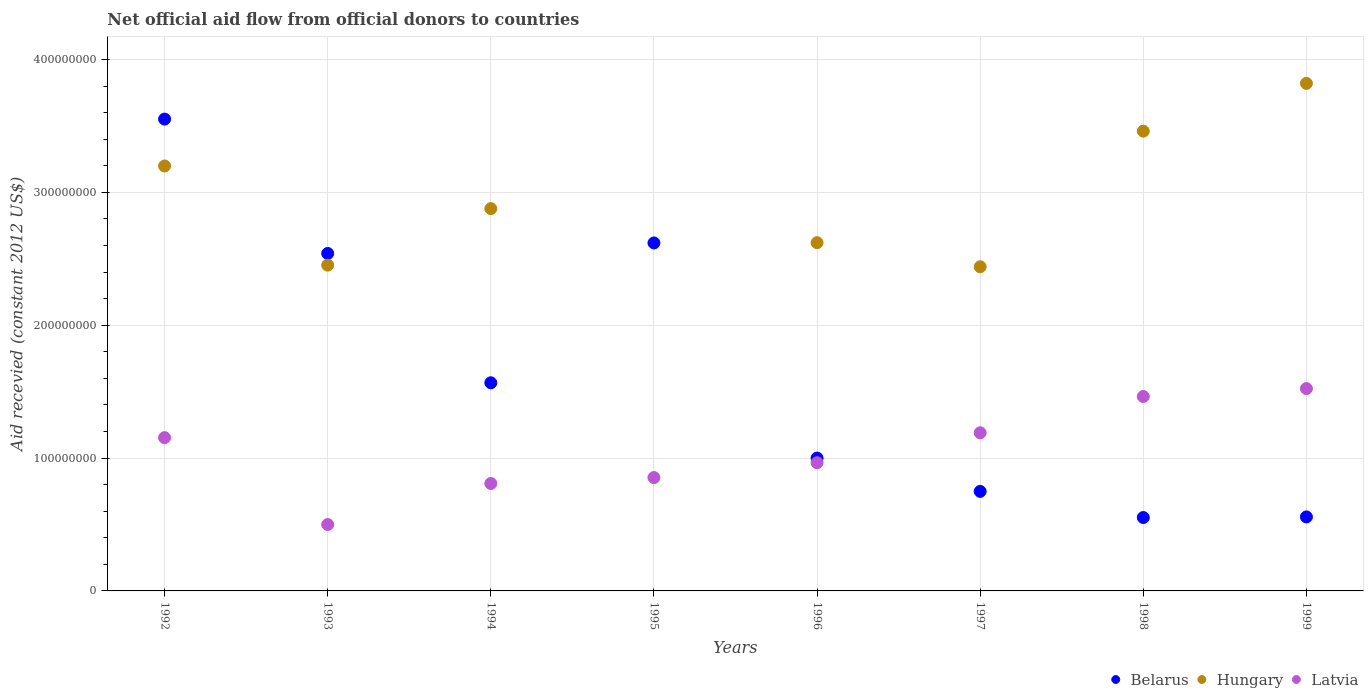How many different coloured dotlines are there?
Provide a succinct answer. 3. Is the number of dotlines equal to the number of legend labels?
Give a very brief answer. No. What is the total aid received in Hungary in 1997?
Provide a short and direct response. 2.44e+08. Across all years, what is the maximum total aid received in Belarus?
Your response must be concise. 3.55e+08. Across all years, what is the minimum total aid received in Latvia?
Give a very brief answer. 5.00e+07. What is the total total aid received in Belarus in the graph?
Keep it short and to the point. 1.31e+09. What is the difference between the total aid received in Latvia in 1993 and that in 1998?
Provide a succinct answer. -9.64e+07. What is the difference between the total aid received in Belarus in 1992 and the total aid received in Latvia in 1999?
Your response must be concise. 2.03e+08. What is the average total aid received in Hungary per year?
Keep it short and to the point. 2.61e+08. In the year 1997, what is the difference between the total aid received in Belarus and total aid received in Hungary?
Your answer should be compact. -1.69e+08. In how many years, is the total aid received in Latvia greater than 100000000 US$?
Provide a succinct answer. 4. What is the ratio of the total aid received in Belarus in 1995 to that in 1999?
Your response must be concise. 4.7. What is the difference between the highest and the second highest total aid received in Latvia?
Offer a very short reply. 5.96e+06. What is the difference between the highest and the lowest total aid received in Belarus?
Make the answer very short. 3.00e+08. Is the sum of the total aid received in Latvia in 1995 and 1997 greater than the maximum total aid received in Belarus across all years?
Your response must be concise. No. Is it the case that in every year, the sum of the total aid received in Latvia and total aid received in Hungary  is greater than the total aid received in Belarus?
Keep it short and to the point. No. Is the total aid received in Hungary strictly greater than the total aid received in Belarus over the years?
Make the answer very short. No. How many dotlines are there?
Keep it short and to the point. 3. Where does the legend appear in the graph?
Offer a very short reply. Bottom right. How many legend labels are there?
Ensure brevity in your answer.  3. What is the title of the graph?
Give a very brief answer. Net official aid flow from official donors to countries. Does "Channel Islands" appear as one of the legend labels in the graph?
Your answer should be compact. No. What is the label or title of the X-axis?
Ensure brevity in your answer.  Years. What is the label or title of the Y-axis?
Ensure brevity in your answer.  Aid recevied (constant 2012 US$). What is the Aid recevied (constant 2012 US$) of Belarus in 1992?
Offer a very short reply. 3.55e+08. What is the Aid recevied (constant 2012 US$) of Hungary in 1992?
Keep it short and to the point. 3.20e+08. What is the Aid recevied (constant 2012 US$) in Latvia in 1992?
Make the answer very short. 1.15e+08. What is the Aid recevied (constant 2012 US$) in Belarus in 1993?
Ensure brevity in your answer.  2.54e+08. What is the Aid recevied (constant 2012 US$) in Hungary in 1993?
Keep it short and to the point. 2.45e+08. What is the Aid recevied (constant 2012 US$) in Latvia in 1993?
Ensure brevity in your answer.  5.00e+07. What is the Aid recevied (constant 2012 US$) in Belarus in 1994?
Give a very brief answer. 1.57e+08. What is the Aid recevied (constant 2012 US$) of Hungary in 1994?
Your response must be concise. 2.88e+08. What is the Aid recevied (constant 2012 US$) in Latvia in 1994?
Offer a very short reply. 8.09e+07. What is the Aid recevied (constant 2012 US$) of Belarus in 1995?
Keep it short and to the point. 2.62e+08. What is the Aid recevied (constant 2012 US$) of Latvia in 1995?
Offer a terse response. 8.53e+07. What is the Aid recevied (constant 2012 US$) of Hungary in 1996?
Make the answer very short. 2.62e+08. What is the Aid recevied (constant 2012 US$) in Latvia in 1996?
Keep it short and to the point. 9.65e+07. What is the Aid recevied (constant 2012 US$) in Belarus in 1997?
Give a very brief answer. 7.49e+07. What is the Aid recevied (constant 2012 US$) of Hungary in 1997?
Provide a succinct answer. 2.44e+08. What is the Aid recevied (constant 2012 US$) in Latvia in 1997?
Your response must be concise. 1.19e+08. What is the Aid recevied (constant 2012 US$) in Belarus in 1998?
Your response must be concise. 5.52e+07. What is the Aid recevied (constant 2012 US$) of Hungary in 1998?
Make the answer very short. 3.46e+08. What is the Aid recevied (constant 2012 US$) of Latvia in 1998?
Your response must be concise. 1.46e+08. What is the Aid recevied (constant 2012 US$) in Belarus in 1999?
Your response must be concise. 5.57e+07. What is the Aid recevied (constant 2012 US$) of Hungary in 1999?
Make the answer very short. 3.82e+08. What is the Aid recevied (constant 2012 US$) in Latvia in 1999?
Make the answer very short. 1.52e+08. Across all years, what is the maximum Aid recevied (constant 2012 US$) in Belarus?
Keep it short and to the point. 3.55e+08. Across all years, what is the maximum Aid recevied (constant 2012 US$) in Hungary?
Make the answer very short. 3.82e+08. Across all years, what is the maximum Aid recevied (constant 2012 US$) of Latvia?
Offer a terse response. 1.52e+08. Across all years, what is the minimum Aid recevied (constant 2012 US$) of Belarus?
Give a very brief answer. 5.52e+07. Across all years, what is the minimum Aid recevied (constant 2012 US$) of Hungary?
Offer a terse response. 0. Across all years, what is the minimum Aid recevied (constant 2012 US$) in Latvia?
Keep it short and to the point. 5.00e+07. What is the total Aid recevied (constant 2012 US$) of Belarus in the graph?
Ensure brevity in your answer.  1.31e+09. What is the total Aid recevied (constant 2012 US$) in Hungary in the graph?
Provide a short and direct response. 2.09e+09. What is the total Aid recevied (constant 2012 US$) in Latvia in the graph?
Keep it short and to the point. 8.46e+08. What is the difference between the Aid recevied (constant 2012 US$) of Belarus in 1992 and that in 1993?
Give a very brief answer. 1.01e+08. What is the difference between the Aid recevied (constant 2012 US$) in Hungary in 1992 and that in 1993?
Keep it short and to the point. 7.46e+07. What is the difference between the Aid recevied (constant 2012 US$) of Latvia in 1992 and that in 1993?
Make the answer very short. 6.54e+07. What is the difference between the Aid recevied (constant 2012 US$) in Belarus in 1992 and that in 1994?
Provide a succinct answer. 1.98e+08. What is the difference between the Aid recevied (constant 2012 US$) in Hungary in 1992 and that in 1994?
Ensure brevity in your answer.  3.21e+07. What is the difference between the Aid recevied (constant 2012 US$) of Latvia in 1992 and that in 1994?
Provide a short and direct response. 3.45e+07. What is the difference between the Aid recevied (constant 2012 US$) in Belarus in 1992 and that in 1995?
Give a very brief answer. 9.32e+07. What is the difference between the Aid recevied (constant 2012 US$) in Latvia in 1992 and that in 1995?
Offer a very short reply. 3.00e+07. What is the difference between the Aid recevied (constant 2012 US$) of Belarus in 1992 and that in 1996?
Offer a terse response. 2.55e+08. What is the difference between the Aid recevied (constant 2012 US$) of Hungary in 1992 and that in 1996?
Provide a short and direct response. 5.77e+07. What is the difference between the Aid recevied (constant 2012 US$) in Latvia in 1992 and that in 1996?
Your answer should be compact. 1.88e+07. What is the difference between the Aid recevied (constant 2012 US$) of Belarus in 1992 and that in 1997?
Provide a short and direct response. 2.80e+08. What is the difference between the Aid recevied (constant 2012 US$) in Hungary in 1992 and that in 1997?
Ensure brevity in your answer.  7.59e+07. What is the difference between the Aid recevied (constant 2012 US$) in Latvia in 1992 and that in 1997?
Provide a succinct answer. -3.67e+06. What is the difference between the Aid recevied (constant 2012 US$) in Belarus in 1992 and that in 1998?
Keep it short and to the point. 3.00e+08. What is the difference between the Aid recevied (constant 2012 US$) in Hungary in 1992 and that in 1998?
Make the answer very short. -2.62e+07. What is the difference between the Aid recevied (constant 2012 US$) in Latvia in 1992 and that in 1998?
Make the answer very short. -3.10e+07. What is the difference between the Aid recevied (constant 2012 US$) of Belarus in 1992 and that in 1999?
Keep it short and to the point. 2.99e+08. What is the difference between the Aid recevied (constant 2012 US$) in Hungary in 1992 and that in 1999?
Give a very brief answer. -6.22e+07. What is the difference between the Aid recevied (constant 2012 US$) of Latvia in 1992 and that in 1999?
Provide a succinct answer. -3.69e+07. What is the difference between the Aid recevied (constant 2012 US$) in Belarus in 1993 and that in 1994?
Give a very brief answer. 9.74e+07. What is the difference between the Aid recevied (constant 2012 US$) in Hungary in 1993 and that in 1994?
Offer a terse response. -4.25e+07. What is the difference between the Aid recevied (constant 2012 US$) of Latvia in 1993 and that in 1994?
Offer a terse response. -3.09e+07. What is the difference between the Aid recevied (constant 2012 US$) in Belarus in 1993 and that in 1995?
Offer a very short reply. -7.91e+06. What is the difference between the Aid recevied (constant 2012 US$) in Latvia in 1993 and that in 1995?
Your answer should be very brief. -3.54e+07. What is the difference between the Aid recevied (constant 2012 US$) of Belarus in 1993 and that in 1996?
Provide a succinct answer. 1.54e+08. What is the difference between the Aid recevied (constant 2012 US$) in Hungary in 1993 and that in 1996?
Your response must be concise. -1.69e+07. What is the difference between the Aid recevied (constant 2012 US$) in Latvia in 1993 and that in 1996?
Your response must be concise. -4.66e+07. What is the difference between the Aid recevied (constant 2012 US$) in Belarus in 1993 and that in 1997?
Offer a very short reply. 1.79e+08. What is the difference between the Aid recevied (constant 2012 US$) in Hungary in 1993 and that in 1997?
Offer a very short reply. 1.23e+06. What is the difference between the Aid recevied (constant 2012 US$) of Latvia in 1993 and that in 1997?
Offer a terse response. -6.91e+07. What is the difference between the Aid recevied (constant 2012 US$) in Belarus in 1993 and that in 1998?
Make the answer very short. 1.99e+08. What is the difference between the Aid recevied (constant 2012 US$) in Hungary in 1993 and that in 1998?
Ensure brevity in your answer.  -1.01e+08. What is the difference between the Aid recevied (constant 2012 US$) of Latvia in 1993 and that in 1998?
Your answer should be compact. -9.64e+07. What is the difference between the Aid recevied (constant 2012 US$) of Belarus in 1993 and that in 1999?
Your answer should be very brief. 1.98e+08. What is the difference between the Aid recevied (constant 2012 US$) of Hungary in 1993 and that in 1999?
Your answer should be very brief. -1.37e+08. What is the difference between the Aid recevied (constant 2012 US$) of Latvia in 1993 and that in 1999?
Your response must be concise. -1.02e+08. What is the difference between the Aid recevied (constant 2012 US$) in Belarus in 1994 and that in 1995?
Your response must be concise. -1.05e+08. What is the difference between the Aid recevied (constant 2012 US$) of Latvia in 1994 and that in 1995?
Your response must be concise. -4.45e+06. What is the difference between the Aid recevied (constant 2012 US$) in Belarus in 1994 and that in 1996?
Provide a succinct answer. 5.67e+07. What is the difference between the Aid recevied (constant 2012 US$) in Hungary in 1994 and that in 1996?
Keep it short and to the point. 2.56e+07. What is the difference between the Aid recevied (constant 2012 US$) of Latvia in 1994 and that in 1996?
Your answer should be compact. -1.57e+07. What is the difference between the Aid recevied (constant 2012 US$) in Belarus in 1994 and that in 1997?
Ensure brevity in your answer.  8.17e+07. What is the difference between the Aid recevied (constant 2012 US$) in Hungary in 1994 and that in 1997?
Ensure brevity in your answer.  4.38e+07. What is the difference between the Aid recevied (constant 2012 US$) of Latvia in 1994 and that in 1997?
Make the answer very short. -3.82e+07. What is the difference between the Aid recevied (constant 2012 US$) of Belarus in 1994 and that in 1998?
Keep it short and to the point. 1.01e+08. What is the difference between the Aid recevied (constant 2012 US$) of Hungary in 1994 and that in 1998?
Your answer should be very brief. -5.83e+07. What is the difference between the Aid recevied (constant 2012 US$) in Latvia in 1994 and that in 1998?
Provide a short and direct response. -6.55e+07. What is the difference between the Aid recevied (constant 2012 US$) of Belarus in 1994 and that in 1999?
Offer a terse response. 1.01e+08. What is the difference between the Aid recevied (constant 2012 US$) in Hungary in 1994 and that in 1999?
Ensure brevity in your answer.  -9.42e+07. What is the difference between the Aid recevied (constant 2012 US$) of Latvia in 1994 and that in 1999?
Your response must be concise. -7.14e+07. What is the difference between the Aid recevied (constant 2012 US$) in Belarus in 1995 and that in 1996?
Offer a terse response. 1.62e+08. What is the difference between the Aid recevied (constant 2012 US$) of Latvia in 1995 and that in 1996?
Make the answer very short. -1.12e+07. What is the difference between the Aid recevied (constant 2012 US$) in Belarus in 1995 and that in 1997?
Your response must be concise. 1.87e+08. What is the difference between the Aid recevied (constant 2012 US$) of Latvia in 1995 and that in 1997?
Your response must be concise. -3.37e+07. What is the difference between the Aid recevied (constant 2012 US$) in Belarus in 1995 and that in 1998?
Provide a succinct answer. 2.07e+08. What is the difference between the Aid recevied (constant 2012 US$) of Latvia in 1995 and that in 1998?
Your response must be concise. -6.10e+07. What is the difference between the Aid recevied (constant 2012 US$) of Belarus in 1995 and that in 1999?
Offer a very short reply. 2.06e+08. What is the difference between the Aid recevied (constant 2012 US$) of Latvia in 1995 and that in 1999?
Ensure brevity in your answer.  -6.70e+07. What is the difference between the Aid recevied (constant 2012 US$) of Belarus in 1996 and that in 1997?
Give a very brief answer. 2.51e+07. What is the difference between the Aid recevied (constant 2012 US$) in Hungary in 1996 and that in 1997?
Provide a short and direct response. 1.81e+07. What is the difference between the Aid recevied (constant 2012 US$) in Latvia in 1996 and that in 1997?
Give a very brief answer. -2.25e+07. What is the difference between the Aid recevied (constant 2012 US$) in Belarus in 1996 and that in 1998?
Make the answer very short. 4.48e+07. What is the difference between the Aid recevied (constant 2012 US$) of Hungary in 1996 and that in 1998?
Provide a succinct answer. -8.40e+07. What is the difference between the Aid recevied (constant 2012 US$) in Latvia in 1996 and that in 1998?
Provide a succinct answer. -4.98e+07. What is the difference between the Aid recevied (constant 2012 US$) of Belarus in 1996 and that in 1999?
Offer a very short reply. 4.43e+07. What is the difference between the Aid recevied (constant 2012 US$) in Hungary in 1996 and that in 1999?
Provide a short and direct response. -1.20e+08. What is the difference between the Aid recevied (constant 2012 US$) in Latvia in 1996 and that in 1999?
Offer a very short reply. -5.58e+07. What is the difference between the Aid recevied (constant 2012 US$) of Belarus in 1997 and that in 1998?
Ensure brevity in your answer.  1.97e+07. What is the difference between the Aid recevied (constant 2012 US$) in Hungary in 1997 and that in 1998?
Provide a short and direct response. -1.02e+08. What is the difference between the Aid recevied (constant 2012 US$) in Latvia in 1997 and that in 1998?
Make the answer very short. -2.73e+07. What is the difference between the Aid recevied (constant 2012 US$) in Belarus in 1997 and that in 1999?
Your response must be concise. 1.92e+07. What is the difference between the Aid recevied (constant 2012 US$) in Hungary in 1997 and that in 1999?
Your answer should be very brief. -1.38e+08. What is the difference between the Aid recevied (constant 2012 US$) in Latvia in 1997 and that in 1999?
Your response must be concise. -3.33e+07. What is the difference between the Aid recevied (constant 2012 US$) of Belarus in 1998 and that in 1999?
Offer a very short reply. -4.70e+05. What is the difference between the Aid recevied (constant 2012 US$) of Hungary in 1998 and that in 1999?
Offer a very short reply. -3.59e+07. What is the difference between the Aid recevied (constant 2012 US$) of Latvia in 1998 and that in 1999?
Offer a terse response. -5.96e+06. What is the difference between the Aid recevied (constant 2012 US$) in Belarus in 1992 and the Aid recevied (constant 2012 US$) in Hungary in 1993?
Your answer should be compact. 1.10e+08. What is the difference between the Aid recevied (constant 2012 US$) of Belarus in 1992 and the Aid recevied (constant 2012 US$) of Latvia in 1993?
Provide a short and direct response. 3.05e+08. What is the difference between the Aid recevied (constant 2012 US$) in Hungary in 1992 and the Aid recevied (constant 2012 US$) in Latvia in 1993?
Your answer should be very brief. 2.70e+08. What is the difference between the Aid recevied (constant 2012 US$) in Belarus in 1992 and the Aid recevied (constant 2012 US$) in Hungary in 1994?
Your response must be concise. 6.74e+07. What is the difference between the Aid recevied (constant 2012 US$) of Belarus in 1992 and the Aid recevied (constant 2012 US$) of Latvia in 1994?
Give a very brief answer. 2.74e+08. What is the difference between the Aid recevied (constant 2012 US$) in Hungary in 1992 and the Aid recevied (constant 2012 US$) in Latvia in 1994?
Offer a terse response. 2.39e+08. What is the difference between the Aid recevied (constant 2012 US$) of Belarus in 1992 and the Aid recevied (constant 2012 US$) of Latvia in 1995?
Your response must be concise. 2.70e+08. What is the difference between the Aid recevied (constant 2012 US$) in Hungary in 1992 and the Aid recevied (constant 2012 US$) in Latvia in 1995?
Your answer should be very brief. 2.35e+08. What is the difference between the Aid recevied (constant 2012 US$) in Belarus in 1992 and the Aid recevied (constant 2012 US$) in Hungary in 1996?
Make the answer very short. 9.30e+07. What is the difference between the Aid recevied (constant 2012 US$) in Belarus in 1992 and the Aid recevied (constant 2012 US$) in Latvia in 1996?
Provide a succinct answer. 2.59e+08. What is the difference between the Aid recevied (constant 2012 US$) in Hungary in 1992 and the Aid recevied (constant 2012 US$) in Latvia in 1996?
Offer a terse response. 2.23e+08. What is the difference between the Aid recevied (constant 2012 US$) in Belarus in 1992 and the Aid recevied (constant 2012 US$) in Hungary in 1997?
Provide a succinct answer. 1.11e+08. What is the difference between the Aid recevied (constant 2012 US$) of Belarus in 1992 and the Aid recevied (constant 2012 US$) of Latvia in 1997?
Offer a very short reply. 2.36e+08. What is the difference between the Aid recevied (constant 2012 US$) of Hungary in 1992 and the Aid recevied (constant 2012 US$) of Latvia in 1997?
Keep it short and to the point. 2.01e+08. What is the difference between the Aid recevied (constant 2012 US$) of Belarus in 1992 and the Aid recevied (constant 2012 US$) of Hungary in 1998?
Provide a succinct answer. 9.06e+06. What is the difference between the Aid recevied (constant 2012 US$) of Belarus in 1992 and the Aid recevied (constant 2012 US$) of Latvia in 1998?
Provide a short and direct response. 2.09e+08. What is the difference between the Aid recevied (constant 2012 US$) of Hungary in 1992 and the Aid recevied (constant 2012 US$) of Latvia in 1998?
Keep it short and to the point. 1.74e+08. What is the difference between the Aid recevied (constant 2012 US$) in Belarus in 1992 and the Aid recevied (constant 2012 US$) in Hungary in 1999?
Your response must be concise. -2.69e+07. What is the difference between the Aid recevied (constant 2012 US$) in Belarus in 1992 and the Aid recevied (constant 2012 US$) in Latvia in 1999?
Keep it short and to the point. 2.03e+08. What is the difference between the Aid recevied (constant 2012 US$) of Hungary in 1992 and the Aid recevied (constant 2012 US$) of Latvia in 1999?
Give a very brief answer. 1.68e+08. What is the difference between the Aid recevied (constant 2012 US$) in Belarus in 1993 and the Aid recevied (constant 2012 US$) in Hungary in 1994?
Ensure brevity in your answer.  -3.38e+07. What is the difference between the Aid recevied (constant 2012 US$) of Belarus in 1993 and the Aid recevied (constant 2012 US$) of Latvia in 1994?
Offer a terse response. 1.73e+08. What is the difference between the Aid recevied (constant 2012 US$) of Hungary in 1993 and the Aid recevied (constant 2012 US$) of Latvia in 1994?
Your response must be concise. 1.64e+08. What is the difference between the Aid recevied (constant 2012 US$) of Belarus in 1993 and the Aid recevied (constant 2012 US$) of Latvia in 1995?
Your answer should be compact. 1.69e+08. What is the difference between the Aid recevied (constant 2012 US$) of Hungary in 1993 and the Aid recevied (constant 2012 US$) of Latvia in 1995?
Make the answer very short. 1.60e+08. What is the difference between the Aid recevied (constant 2012 US$) of Belarus in 1993 and the Aid recevied (constant 2012 US$) of Hungary in 1996?
Your answer should be very brief. -8.11e+06. What is the difference between the Aid recevied (constant 2012 US$) of Belarus in 1993 and the Aid recevied (constant 2012 US$) of Latvia in 1996?
Your answer should be very brief. 1.57e+08. What is the difference between the Aid recevied (constant 2012 US$) in Hungary in 1993 and the Aid recevied (constant 2012 US$) in Latvia in 1996?
Provide a short and direct response. 1.49e+08. What is the difference between the Aid recevied (constant 2012 US$) in Belarus in 1993 and the Aid recevied (constant 2012 US$) in Hungary in 1997?
Make the answer very short. 1.00e+07. What is the difference between the Aid recevied (constant 2012 US$) in Belarus in 1993 and the Aid recevied (constant 2012 US$) in Latvia in 1997?
Make the answer very short. 1.35e+08. What is the difference between the Aid recevied (constant 2012 US$) of Hungary in 1993 and the Aid recevied (constant 2012 US$) of Latvia in 1997?
Your answer should be compact. 1.26e+08. What is the difference between the Aid recevied (constant 2012 US$) in Belarus in 1993 and the Aid recevied (constant 2012 US$) in Hungary in 1998?
Your answer should be very brief. -9.21e+07. What is the difference between the Aid recevied (constant 2012 US$) in Belarus in 1993 and the Aid recevied (constant 2012 US$) in Latvia in 1998?
Give a very brief answer. 1.08e+08. What is the difference between the Aid recevied (constant 2012 US$) of Hungary in 1993 and the Aid recevied (constant 2012 US$) of Latvia in 1998?
Offer a terse response. 9.89e+07. What is the difference between the Aid recevied (constant 2012 US$) in Belarus in 1993 and the Aid recevied (constant 2012 US$) in Hungary in 1999?
Your answer should be very brief. -1.28e+08. What is the difference between the Aid recevied (constant 2012 US$) in Belarus in 1993 and the Aid recevied (constant 2012 US$) in Latvia in 1999?
Provide a short and direct response. 1.02e+08. What is the difference between the Aid recevied (constant 2012 US$) of Hungary in 1993 and the Aid recevied (constant 2012 US$) of Latvia in 1999?
Offer a terse response. 9.29e+07. What is the difference between the Aid recevied (constant 2012 US$) of Belarus in 1994 and the Aid recevied (constant 2012 US$) of Latvia in 1995?
Make the answer very short. 7.13e+07. What is the difference between the Aid recevied (constant 2012 US$) of Hungary in 1994 and the Aid recevied (constant 2012 US$) of Latvia in 1995?
Make the answer very short. 2.02e+08. What is the difference between the Aid recevied (constant 2012 US$) in Belarus in 1994 and the Aid recevied (constant 2012 US$) in Hungary in 1996?
Offer a terse response. -1.05e+08. What is the difference between the Aid recevied (constant 2012 US$) of Belarus in 1994 and the Aid recevied (constant 2012 US$) of Latvia in 1996?
Ensure brevity in your answer.  6.01e+07. What is the difference between the Aid recevied (constant 2012 US$) in Hungary in 1994 and the Aid recevied (constant 2012 US$) in Latvia in 1996?
Your answer should be compact. 1.91e+08. What is the difference between the Aid recevied (constant 2012 US$) in Belarus in 1994 and the Aid recevied (constant 2012 US$) in Hungary in 1997?
Keep it short and to the point. -8.73e+07. What is the difference between the Aid recevied (constant 2012 US$) of Belarus in 1994 and the Aid recevied (constant 2012 US$) of Latvia in 1997?
Offer a terse response. 3.76e+07. What is the difference between the Aid recevied (constant 2012 US$) of Hungary in 1994 and the Aid recevied (constant 2012 US$) of Latvia in 1997?
Give a very brief answer. 1.69e+08. What is the difference between the Aid recevied (constant 2012 US$) in Belarus in 1994 and the Aid recevied (constant 2012 US$) in Hungary in 1998?
Provide a short and direct response. -1.89e+08. What is the difference between the Aid recevied (constant 2012 US$) in Belarus in 1994 and the Aid recevied (constant 2012 US$) in Latvia in 1998?
Your answer should be compact. 1.03e+07. What is the difference between the Aid recevied (constant 2012 US$) of Hungary in 1994 and the Aid recevied (constant 2012 US$) of Latvia in 1998?
Your response must be concise. 1.41e+08. What is the difference between the Aid recevied (constant 2012 US$) in Belarus in 1994 and the Aid recevied (constant 2012 US$) in Hungary in 1999?
Offer a terse response. -2.25e+08. What is the difference between the Aid recevied (constant 2012 US$) of Belarus in 1994 and the Aid recevied (constant 2012 US$) of Latvia in 1999?
Offer a terse response. 4.35e+06. What is the difference between the Aid recevied (constant 2012 US$) in Hungary in 1994 and the Aid recevied (constant 2012 US$) in Latvia in 1999?
Your answer should be very brief. 1.35e+08. What is the difference between the Aid recevied (constant 2012 US$) in Belarus in 1995 and the Aid recevied (constant 2012 US$) in Hungary in 1996?
Keep it short and to the point. -2.00e+05. What is the difference between the Aid recevied (constant 2012 US$) in Belarus in 1995 and the Aid recevied (constant 2012 US$) in Latvia in 1996?
Offer a very short reply. 1.65e+08. What is the difference between the Aid recevied (constant 2012 US$) in Belarus in 1995 and the Aid recevied (constant 2012 US$) in Hungary in 1997?
Keep it short and to the point. 1.79e+07. What is the difference between the Aid recevied (constant 2012 US$) of Belarus in 1995 and the Aid recevied (constant 2012 US$) of Latvia in 1997?
Your answer should be very brief. 1.43e+08. What is the difference between the Aid recevied (constant 2012 US$) of Belarus in 1995 and the Aid recevied (constant 2012 US$) of Hungary in 1998?
Keep it short and to the point. -8.42e+07. What is the difference between the Aid recevied (constant 2012 US$) in Belarus in 1995 and the Aid recevied (constant 2012 US$) in Latvia in 1998?
Offer a terse response. 1.16e+08. What is the difference between the Aid recevied (constant 2012 US$) of Belarus in 1995 and the Aid recevied (constant 2012 US$) of Hungary in 1999?
Make the answer very short. -1.20e+08. What is the difference between the Aid recevied (constant 2012 US$) in Belarus in 1995 and the Aid recevied (constant 2012 US$) in Latvia in 1999?
Your answer should be compact. 1.10e+08. What is the difference between the Aid recevied (constant 2012 US$) of Belarus in 1996 and the Aid recevied (constant 2012 US$) of Hungary in 1997?
Make the answer very short. -1.44e+08. What is the difference between the Aid recevied (constant 2012 US$) of Belarus in 1996 and the Aid recevied (constant 2012 US$) of Latvia in 1997?
Make the answer very short. -1.90e+07. What is the difference between the Aid recevied (constant 2012 US$) in Hungary in 1996 and the Aid recevied (constant 2012 US$) in Latvia in 1997?
Provide a short and direct response. 1.43e+08. What is the difference between the Aid recevied (constant 2012 US$) of Belarus in 1996 and the Aid recevied (constant 2012 US$) of Hungary in 1998?
Keep it short and to the point. -2.46e+08. What is the difference between the Aid recevied (constant 2012 US$) in Belarus in 1996 and the Aid recevied (constant 2012 US$) in Latvia in 1998?
Provide a short and direct response. -4.64e+07. What is the difference between the Aid recevied (constant 2012 US$) of Hungary in 1996 and the Aid recevied (constant 2012 US$) of Latvia in 1998?
Ensure brevity in your answer.  1.16e+08. What is the difference between the Aid recevied (constant 2012 US$) of Belarus in 1996 and the Aid recevied (constant 2012 US$) of Hungary in 1999?
Provide a short and direct response. -2.82e+08. What is the difference between the Aid recevied (constant 2012 US$) in Belarus in 1996 and the Aid recevied (constant 2012 US$) in Latvia in 1999?
Give a very brief answer. -5.23e+07. What is the difference between the Aid recevied (constant 2012 US$) in Hungary in 1996 and the Aid recevied (constant 2012 US$) in Latvia in 1999?
Provide a short and direct response. 1.10e+08. What is the difference between the Aid recevied (constant 2012 US$) of Belarus in 1997 and the Aid recevied (constant 2012 US$) of Hungary in 1998?
Keep it short and to the point. -2.71e+08. What is the difference between the Aid recevied (constant 2012 US$) of Belarus in 1997 and the Aid recevied (constant 2012 US$) of Latvia in 1998?
Keep it short and to the point. -7.14e+07. What is the difference between the Aid recevied (constant 2012 US$) in Hungary in 1997 and the Aid recevied (constant 2012 US$) in Latvia in 1998?
Your answer should be very brief. 9.76e+07. What is the difference between the Aid recevied (constant 2012 US$) of Belarus in 1997 and the Aid recevied (constant 2012 US$) of Hungary in 1999?
Keep it short and to the point. -3.07e+08. What is the difference between the Aid recevied (constant 2012 US$) of Belarus in 1997 and the Aid recevied (constant 2012 US$) of Latvia in 1999?
Your answer should be compact. -7.74e+07. What is the difference between the Aid recevied (constant 2012 US$) in Hungary in 1997 and the Aid recevied (constant 2012 US$) in Latvia in 1999?
Your response must be concise. 9.17e+07. What is the difference between the Aid recevied (constant 2012 US$) in Belarus in 1998 and the Aid recevied (constant 2012 US$) in Hungary in 1999?
Offer a terse response. -3.27e+08. What is the difference between the Aid recevied (constant 2012 US$) in Belarus in 1998 and the Aid recevied (constant 2012 US$) in Latvia in 1999?
Your answer should be compact. -9.71e+07. What is the difference between the Aid recevied (constant 2012 US$) in Hungary in 1998 and the Aid recevied (constant 2012 US$) in Latvia in 1999?
Ensure brevity in your answer.  1.94e+08. What is the average Aid recevied (constant 2012 US$) of Belarus per year?
Keep it short and to the point. 1.64e+08. What is the average Aid recevied (constant 2012 US$) of Hungary per year?
Your answer should be very brief. 2.61e+08. What is the average Aid recevied (constant 2012 US$) of Latvia per year?
Make the answer very short. 1.06e+08. In the year 1992, what is the difference between the Aid recevied (constant 2012 US$) in Belarus and Aid recevied (constant 2012 US$) in Hungary?
Give a very brief answer. 3.53e+07. In the year 1992, what is the difference between the Aid recevied (constant 2012 US$) of Belarus and Aid recevied (constant 2012 US$) of Latvia?
Provide a short and direct response. 2.40e+08. In the year 1992, what is the difference between the Aid recevied (constant 2012 US$) of Hungary and Aid recevied (constant 2012 US$) of Latvia?
Provide a short and direct response. 2.04e+08. In the year 1993, what is the difference between the Aid recevied (constant 2012 US$) in Belarus and Aid recevied (constant 2012 US$) in Hungary?
Make the answer very short. 8.79e+06. In the year 1993, what is the difference between the Aid recevied (constant 2012 US$) of Belarus and Aid recevied (constant 2012 US$) of Latvia?
Keep it short and to the point. 2.04e+08. In the year 1993, what is the difference between the Aid recevied (constant 2012 US$) of Hungary and Aid recevied (constant 2012 US$) of Latvia?
Ensure brevity in your answer.  1.95e+08. In the year 1994, what is the difference between the Aid recevied (constant 2012 US$) of Belarus and Aid recevied (constant 2012 US$) of Hungary?
Offer a very short reply. -1.31e+08. In the year 1994, what is the difference between the Aid recevied (constant 2012 US$) in Belarus and Aid recevied (constant 2012 US$) in Latvia?
Keep it short and to the point. 7.58e+07. In the year 1994, what is the difference between the Aid recevied (constant 2012 US$) in Hungary and Aid recevied (constant 2012 US$) in Latvia?
Keep it short and to the point. 2.07e+08. In the year 1995, what is the difference between the Aid recevied (constant 2012 US$) in Belarus and Aid recevied (constant 2012 US$) in Latvia?
Provide a succinct answer. 1.77e+08. In the year 1996, what is the difference between the Aid recevied (constant 2012 US$) in Belarus and Aid recevied (constant 2012 US$) in Hungary?
Your answer should be very brief. -1.62e+08. In the year 1996, what is the difference between the Aid recevied (constant 2012 US$) of Belarus and Aid recevied (constant 2012 US$) of Latvia?
Give a very brief answer. 3.47e+06. In the year 1996, what is the difference between the Aid recevied (constant 2012 US$) of Hungary and Aid recevied (constant 2012 US$) of Latvia?
Keep it short and to the point. 1.66e+08. In the year 1997, what is the difference between the Aid recevied (constant 2012 US$) in Belarus and Aid recevied (constant 2012 US$) in Hungary?
Give a very brief answer. -1.69e+08. In the year 1997, what is the difference between the Aid recevied (constant 2012 US$) in Belarus and Aid recevied (constant 2012 US$) in Latvia?
Offer a very short reply. -4.41e+07. In the year 1997, what is the difference between the Aid recevied (constant 2012 US$) in Hungary and Aid recevied (constant 2012 US$) in Latvia?
Provide a short and direct response. 1.25e+08. In the year 1998, what is the difference between the Aid recevied (constant 2012 US$) in Belarus and Aid recevied (constant 2012 US$) in Hungary?
Offer a terse response. -2.91e+08. In the year 1998, what is the difference between the Aid recevied (constant 2012 US$) of Belarus and Aid recevied (constant 2012 US$) of Latvia?
Your answer should be compact. -9.11e+07. In the year 1998, what is the difference between the Aid recevied (constant 2012 US$) of Hungary and Aid recevied (constant 2012 US$) of Latvia?
Ensure brevity in your answer.  2.00e+08. In the year 1999, what is the difference between the Aid recevied (constant 2012 US$) of Belarus and Aid recevied (constant 2012 US$) of Hungary?
Make the answer very short. -3.26e+08. In the year 1999, what is the difference between the Aid recevied (constant 2012 US$) of Belarus and Aid recevied (constant 2012 US$) of Latvia?
Keep it short and to the point. -9.66e+07. In the year 1999, what is the difference between the Aid recevied (constant 2012 US$) in Hungary and Aid recevied (constant 2012 US$) in Latvia?
Give a very brief answer. 2.30e+08. What is the ratio of the Aid recevied (constant 2012 US$) of Belarus in 1992 to that in 1993?
Your response must be concise. 1.4. What is the ratio of the Aid recevied (constant 2012 US$) of Hungary in 1992 to that in 1993?
Provide a succinct answer. 1.3. What is the ratio of the Aid recevied (constant 2012 US$) in Latvia in 1992 to that in 1993?
Provide a short and direct response. 2.31. What is the ratio of the Aid recevied (constant 2012 US$) in Belarus in 1992 to that in 1994?
Make the answer very short. 2.27. What is the ratio of the Aid recevied (constant 2012 US$) in Hungary in 1992 to that in 1994?
Provide a short and direct response. 1.11. What is the ratio of the Aid recevied (constant 2012 US$) in Latvia in 1992 to that in 1994?
Provide a succinct answer. 1.43. What is the ratio of the Aid recevied (constant 2012 US$) of Belarus in 1992 to that in 1995?
Provide a short and direct response. 1.36. What is the ratio of the Aid recevied (constant 2012 US$) in Latvia in 1992 to that in 1995?
Your response must be concise. 1.35. What is the ratio of the Aid recevied (constant 2012 US$) of Belarus in 1992 to that in 1996?
Ensure brevity in your answer.  3.55. What is the ratio of the Aid recevied (constant 2012 US$) of Hungary in 1992 to that in 1996?
Your answer should be compact. 1.22. What is the ratio of the Aid recevied (constant 2012 US$) in Latvia in 1992 to that in 1996?
Your answer should be compact. 1.2. What is the ratio of the Aid recevied (constant 2012 US$) in Belarus in 1992 to that in 1997?
Offer a very short reply. 4.74. What is the ratio of the Aid recevied (constant 2012 US$) in Hungary in 1992 to that in 1997?
Offer a very short reply. 1.31. What is the ratio of the Aid recevied (constant 2012 US$) of Latvia in 1992 to that in 1997?
Keep it short and to the point. 0.97. What is the ratio of the Aid recevied (constant 2012 US$) in Belarus in 1992 to that in 1998?
Make the answer very short. 6.43. What is the ratio of the Aid recevied (constant 2012 US$) in Hungary in 1992 to that in 1998?
Provide a short and direct response. 0.92. What is the ratio of the Aid recevied (constant 2012 US$) in Latvia in 1992 to that in 1998?
Ensure brevity in your answer.  0.79. What is the ratio of the Aid recevied (constant 2012 US$) in Belarus in 1992 to that in 1999?
Your response must be concise. 6.37. What is the ratio of the Aid recevied (constant 2012 US$) of Hungary in 1992 to that in 1999?
Your answer should be very brief. 0.84. What is the ratio of the Aid recevied (constant 2012 US$) in Latvia in 1992 to that in 1999?
Ensure brevity in your answer.  0.76. What is the ratio of the Aid recevied (constant 2012 US$) of Belarus in 1993 to that in 1994?
Your answer should be compact. 1.62. What is the ratio of the Aid recevied (constant 2012 US$) in Hungary in 1993 to that in 1994?
Offer a very short reply. 0.85. What is the ratio of the Aid recevied (constant 2012 US$) of Latvia in 1993 to that in 1994?
Ensure brevity in your answer.  0.62. What is the ratio of the Aid recevied (constant 2012 US$) of Belarus in 1993 to that in 1995?
Give a very brief answer. 0.97. What is the ratio of the Aid recevied (constant 2012 US$) in Latvia in 1993 to that in 1995?
Your answer should be very brief. 0.59. What is the ratio of the Aid recevied (constant 2012 US$) in Belarus in 1993 to that in 1996?
Your answer should be very brief. 2.54. What is the ratio of the Aid recevied (constant 2012 US$) of Hungary in 1993 to that in 1996?
Provide a succinct answer. 0.94. What is the ratio of the Aid recevied (constant 2012 US$) of Latvia in 1993 to that in 1996?
Give a very brief answer. 0.52. What is the ratio of the Aid recevied (constant 2012 US$) of Belarus in 1993 to that in 1997?
Provide a succinct answer. 3.39. What is the ratio of the Aid recevied (constant 2012 US$) of Latvia in 1993 to that in 1997?
Provide a short and direct response. 0.42. What is the ratio of the Aid recevied (constant 2012 US$) of Belarus in 1993 to that in 1998?
Give a very brief answer. 4.6. What is the ratio of the Aid recevied (constant 2012 US$) in Hungary in 1993 to that in 1998?
Provide a succinct answer. 0.71. What is the ratio of the Aid recevied (constant 2012 US$) of Latvia in 1993 to that in 1998?
Offer a very short reply. 0.34. What is the ratio of the Aid recevied (constant 2012 US$) of Belarus in 1993 to that in 1999?
Your answer should be very brief. 4.56. What is the ratio of the Aid recevied (constant 2012 US$) of Hungary in 1993 to that in 1999?
Offer a very short reply. 0.64. What is the ratio of the Aid recevied (constant 2012 US$) in Latvia in 1993 to that in 1999?
Give a very brief answer. 0.33. What is the ratio of the Aid recevied (constant 2012 US$) of Belarus in 1994 to that in 1995?
Provide a succinct answer. 0.6. What is the ratio of the Aid recevied (constant 2012 US$) in Latvia in 1994 to that in 1995?
Provide a succinct answer. 0.95. What is the ratio of the Aid recevied (constant 2012 US$) in Belarus in 1994 to that in 1996?
Your answer should be compact. 1.57. What is the ratio of the Aid recevied (constant 2012 US$) in Hungary in 1994 to that in 1996?
Your answer should be very brief. 1.1. What is the ratio of the Aid recevied (constant 2012 US$) in Latvia in 1994 to that in 1996?
Provide a succinct answer. 0.84. What is the ratio of the Aid recevied (constant 2012 US$) in Belarus in 1994 to that in 1997?
Give a very brief answer. 2.09. What is the ratio of the Aid recevied (constant 2012 US$) of Hungary in 1994 to that in 1997?
Provide a succinct answer. 1.18. What is the ratio of the Aid recevied (constant 2012 US$) in Latvia in 1994 to that in 1997?
Your answer should be very brief. 0.68. What is the ratio of the Aid recevied (constant 2012 US$) of Belarus in 1994 to that in 1998?
Provide a short and direct response. 2.84. What is the ratio of the Aid recevied (constant 2012 US$) of Hungary in 1994 to that in 1998?
Keep it short and to the point. 0.83. What is the ratio of the Aid recevied (constant 2012 US$) in Latvia in 1994 to that in 1998?
Ensure brevity in your answer.  0.55. What is the ratio of the Aid recevied (constant 2012 US$) of Belarus in 1994 to that in 1999?
Offer a terse response. 2.81. What is the ratio of the Aid recevied (constant 2012 US$) of Hungary in 1994 to that in 1999?
Offer a very short reply. 0.75. What is the ratio of the Aid recevied (constant 2012 US$) in Latvia in 1994 to that in 1999?
Make the answer very short. 0.53. What is the ratio of the Aid recevied (constant 2012 US$) in Belarus in 1995 to that in 1996?
Make the answer very short. 2.62. What is the ratio of the Aid recevied (constant 2012 US$) of Latvia in 1995 to that in 1996?
Give a very brief answer. 0.88. What is the ratio of the Aid recevied (constant 2012 US$) in Belarus in 1995 to that in 1997?
Provide a succinct answer. 3.5. What is the ratio of the Aid recevied (constant 2012 US$) in Latvia in 1995 to that in 1997?
Make the answer very short. 0.72. What is the ratio of the Aid recevied (constant 2012 US$) in Belarus in 1995 to that in 1998?
Ensure brevity in your answer.  4.74. What is the ratio of the Aid recevied (constant 2012 US$) of Latvia in 1995 to that in 1998?
Give a very brief answer. 0.58. What is the ratio of the Aid recevied (constant 2012 US$) in Belarus in 1995 to that in 1999?
Your answer should be very brief. 4.7. What is the ratio of the Aid recevied (constant 2012 US$) of Latvia in 1995 to that in 1999?
Your response must be concise. 0.56. What is the ratio of the Aid recevied (constant 2012 US$) of Belarus in 1996 to that in 1997?
Ensure brevity in your answer.  1.33. What is the ratio of the Aid recevied (constant 2012 US$) in Hungary in 1996 to that in 1997?
Keep it short and to the point. 1.07. What is the ratio of the Aid recevied (constant 2012 US$) of Latvia in 1996 to that in 1997?
Your response must be concise. 0.81. What is the ratio of the Aid recevied (constant 2012 US$) in Belarus in 1996 to that in 1998?
Make the answer very short. 1.81. What is the ratio of the Aid recevied (constant 2012 US$) in Hungary in 1996 to that in 1998?
Give a very brief answer. 0.76. What is the ratio of the Aid recevied (constant 2012 US$) in Latvia in 1996 to that in 1998?
Your answer should be compact. 0.66. What is the ratio of the Aid recevied (constant 2012 US$) of Belarus in 1996 to that in 1999?
Give a very brief answer. 1.79. What is the ratio of the Aid recevied (constant 2012 US$) of Hungary in 1996 to that in 1999?
Make the answer very short. 0.69. What is the ratio of the Aid recevied (constant 2012 US$) of Latvia in 1996 to that in 1999?
Give a very brief answer. 0.63. What is the ratio of the Aid recevied (constant 2012 US$) of Belarus in 1997 to that in 1998?
Offer a terse response. 1.36. What is the ratio of the Aid recevied (constant 2012 US$) of Hungary in 1997 to that in 1998?
Ensure brevity in your answer.  0.7. What is the ratio of the Aid recevied (constant 2012 US$) in Latvia in 1997 to that in 1998?
Your answer should be very brief. 0.81. What is the ratio of the Aid recevied (constant 2012 US$) of Belarus in 1997 to that in 1999?
Your answer should be compact. 1.34. What is the ratio of the Aid recevied (constant 2012 US$) in Hungary in 1997 to that in 1999?
Your answer should be very brief. 0.64. What is the ratio of the Aid recevied (constant 2012 US$) in Latvia in 1997 to that in 1999?
Provide a short and direct response. 0.78. What is the ratio of the Aid recevied (constant 2012 US$) in Belarus in 1998 to that in 1999?
Keep it short and to the point. 0.99. What is the ratio of the Aid recevied (constant 2012 US$) of Hungary in 1998 to that in 1999?
Provide a succinct answer. 0.91. What is the ratio of the Aid recevied (constant 2012 US$) of Latvia in 1998 to that in 1999?
Give a very brief answer. 0.96. What is the difference between the highest and the second highest Aid recevied (constant 2012 US$) of Belarus?
Provide a succinct answer. 9.32e+07. What is the difference between the highest and the second highest Aid recevied (constant 2012 US$) of Hungary?
Offer a terse response. 3.59e+07. What is the difference between the highest and the second highest Aid recevied (constant 2012 US$) in Latvia?
Provide a short and direct response. 5.96e+06. What is the difference between the highest and the lowest Aid recevied (constant 2012 US$) in Belarus?
Offer a very short reply. 3.00e+08. What is the difference between the highest and the lowest Aid recevied (constant 2012 US$) in Hungary?
Your response must be concise. 3.82e+08. What is the difference between the highest and the lowest Aid recevied (constant 2012 US$) in Latvia?
Provide a short and direct response. 1.02e+08. 